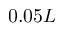Convert formula to latex. <formula><loc_0><loc_0><loc_500><loc_500>0 . 0 5 L</formula> 